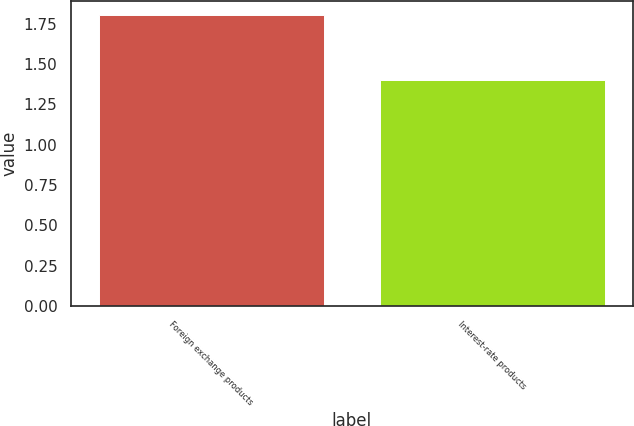<chart> <loc_0><loc_0><loc_500><loc_500><bar_chart><fcel>Foreign exchange products<fcel>Interest-rate products<nl><fcel>1.8<fcel>1.4<nl></chart> 